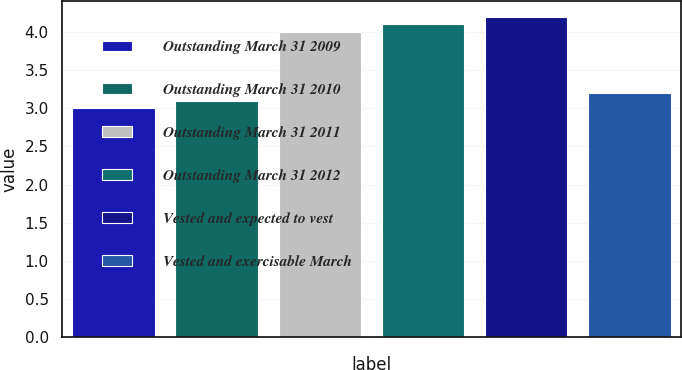Convert chart to OTSL. <chart><loc_0><loc_0><loc_500><loc_500><bar_chart><fcel>Outstanding March 31 2009<fcel>Outstanding March 31 2010<fcel>Outstanding March 31 2011<fcel>Outstanding March 31 2012<fcel>Vested and expected to vest<fcel>Vested and exercisable March<nl><fcel>3<fcel>3.1<fcel>4<fcel>4.1<fcel>4.2<fcel>3.2<nl></chart> 